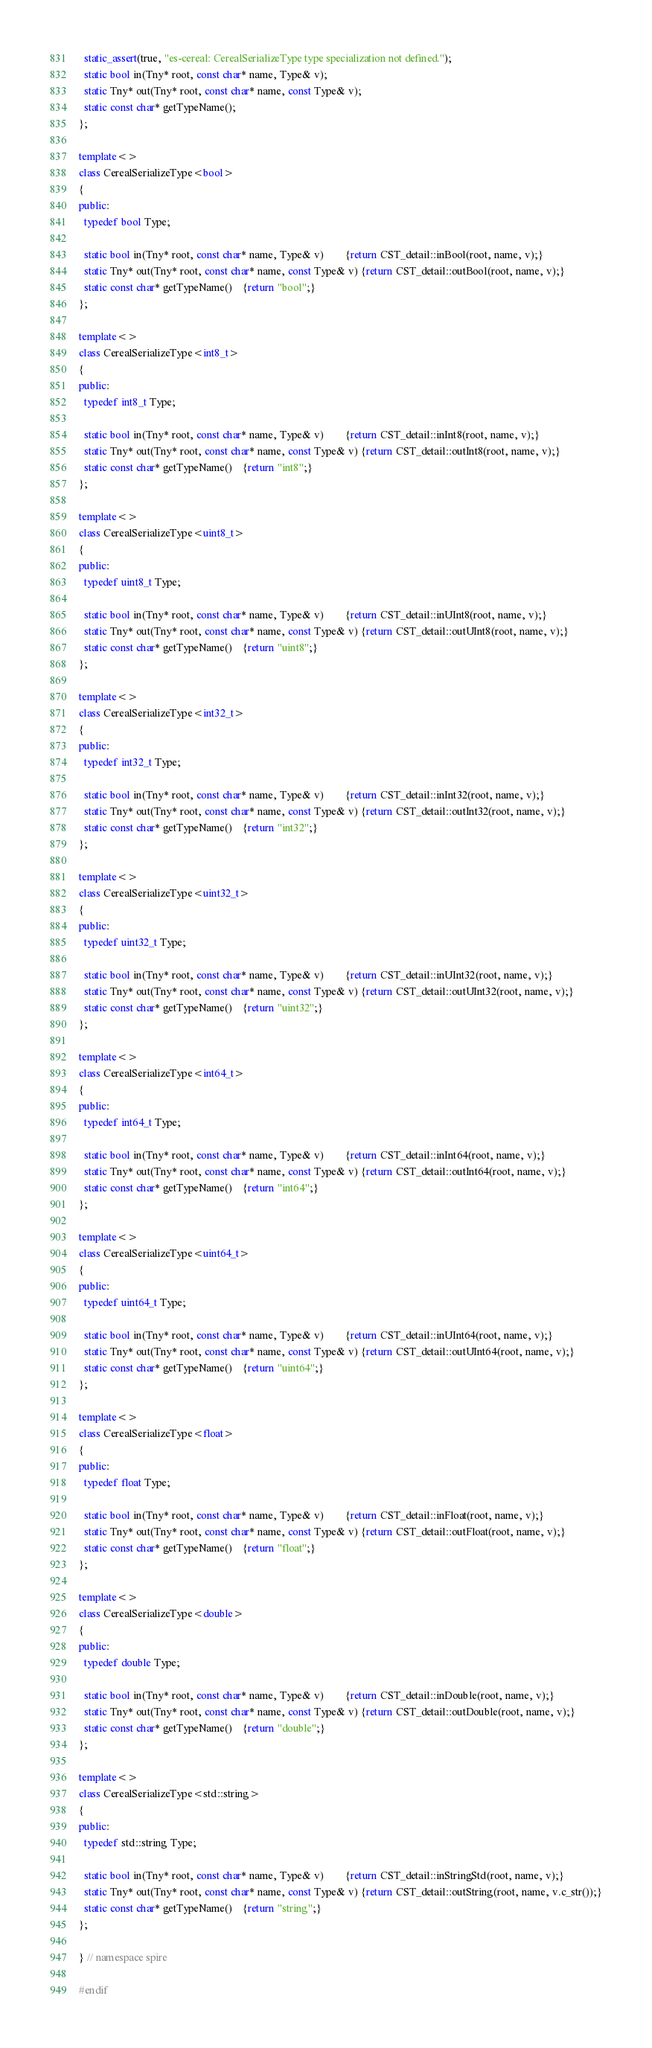<code> <loc_0><loc_0><loc_500><loc_500><_C++_>
  static_assert(true, "es-cereal: CerealSerializeType type specialization not defined.");
  static bool in(Tny* root, const char* name, Type& v);
  static Tny* out(Tny* root, const char* name, const Type& v);
  static const char* getTypeName();
};

template<>
class CerealSerializeType<bool>
{
public:
  typedef bool Type;

  static bool in(Tny* root, const char* name, Type& v)        {return CST_detail::inBool(root, name, v);}
  static Tny* out(Tny* root, const char* name, const Type& v) {return CST_detail::outBool(root, name, v);}
  static const char* getTypeName()    {return "bool";}
};

template<>
class CerealSerializeType<int8_t>
{
public:
  typedef int8_t Type;

  static bool in(Tny* root, const char* name, Type& v)        {return CST_detail::inInt8(root, name, v);}
  static Tny* out(Tny* root, const char* name, const Type& v) {return CST_detail::outInt8(root, name, v);}
  static const char* getTypeName()    {return "int8";}
};

template<>
class CerealSerializeType<uint8_t>
{
public:
  typedef uint8_t Type;

  static bool in(Tny* root, const char* name, Type& v)        {return CST_detail::inUInt8(root, name, v);}
  static Tny* out(Tny* root, const char* name, const Type& v) {return CST_detail::outUInt8(root, name, v);}
  static const char* getTypeName()    {return "uint8";}
};

template<>
class CerealSerializeType<int32_t>
{
public:
  typedef int32_t Type;

  static bool in(Tny* root, const char* name, Type& v)        {return CST_detail::inInt32(root, name, v);}
  static Tny* out(Tny* root, const char* name, const Type& v) {return CST_detail::outInt32(root, name, v);}
  static const char* getTypeName()    {return "int32";}
};

template<>
class CerealSerializeType<uint32_t>
{
public:
  typedef uint32_t Type;

  static bool in(Tny* root, const char* name, Type& v)        {return CST_detail::inUInt32(root, name, v);}
  static Tny* out(Tny* root, const char* name, const Type& v) {return CST_detail::outUInt32(root, name, v);}
  static const char* getTypeName()    {return "uint32";}
};

template<>
class CerealSerializeType<int64_t>
{
public:
  typedef int64_t Type;

  static bool in(Tny* root, const char* name, Type& v)        {return CST_detail::inInt64(root, name, v);}
  static Tny* out(Tny* root, const char* name, const Type& v) {return CST_detail::outInt64(root, name, v);}
  static const char* getTypeName()    {return "int64";}
};

template<>
class CerealSerializeType<uint64_t>
{
public:
  typedef uint64_t Type;

  static bool in(Tny* root, const char* name, Type& v)        {return CST_detail::inUInt64(root, name, v);}
  static Tny* out(Tny* root, const char* name, const Type& v) {return CST_detail::outUInt64(root, name, v);}
  static const char* getTypeName()    {return "uint64";}
};

template<>
class CerealSerializeType<float>
{
public:
  typedef float Type;

  static bool in(Tny* root, const char* name, Type& v)        {return CST_detail::inFloat(root, name, v);}
  static Tny* out(Tny* root, const char* name, const Type& v) {return CST_detail::outFloat(root, name, v);}
  static const char* getTypeName()    {return "float";}
};

template<>
class CerealSerializeType<double>
{
public:
  typedef double Type;

  static bool in(Tny* root, const char* name, Type& v)        {return CST_detail::inDouble(root, name, v);}
  static Tny* out(Tny* root, const char* name, const Type& v) {return CST_detail::outDouble(root, name, v);}
  static const char* getTypeName()    {return "double";}
};

template<>
class CerealSerializeType<std::string>
{
public:
  typedef std::string Type;

  static bool in(Tny* root, const char* name, Type& v)        {return CST_detail::inStringStd(root, name, v);}
  static Tny* out(Tny* root, const char* name, const Type& v) {return CST_detail::outString(root, name, v.c_str());}
  static const char* getTypeName()    {return "string";}
};

} // namespace spire

#endif
</code> 